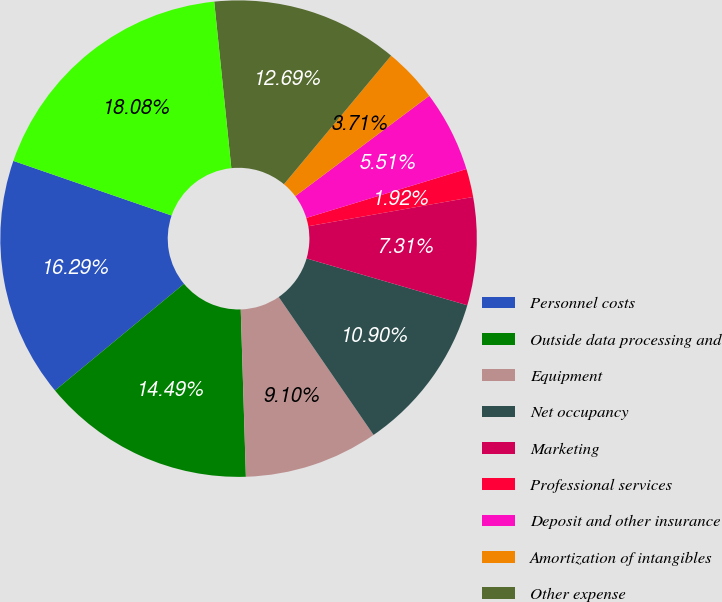Convert chart. <chart><loc_0><loc_0><loc_500><loc_500><pie_chart><fcel>Personnel costs<fcel>Outside data processing and<fcel>Equipment<fcel>Net occupancy<fcel>Marketing<fcel>Professional services<fcel>Deposit and other insurance<fcel>Amortization of intangibles<fcel>Other expense<fcel>Total noninterest expense<nl><fcel>16.29%<fcel>14.49%<fcel>9.1%<fcel>10.9%<fcel>7.31%<fcel>1.92%<fcel>5.51%<fcel>3.71%<fcel>12.69%<fcel>18.08%<nl></chart> 